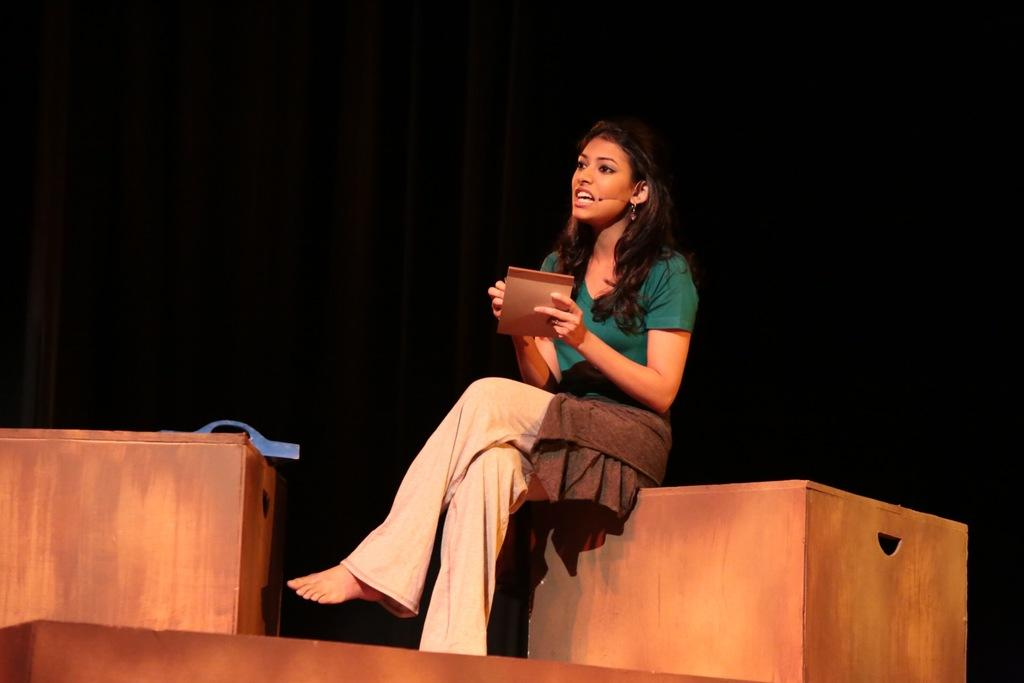Who is the main subject in the image? There is a lady in the image. What is the lady sitting on? The lady is sitting on a wooden block. What color is the background of the image? The background of the image is black in color. Can you see any toys in the image? There are no toys present in the image. Are there any bees buzzing around the lady in the image? There are no bees visible in the image. 